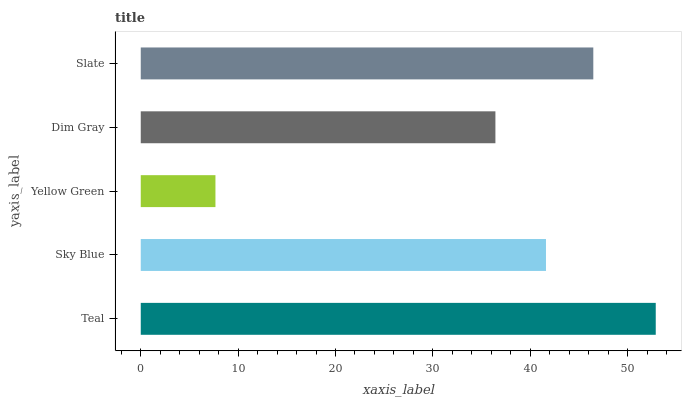Is Yellow Green the minimum?
Answer yes or no. Yes. Is Teal the maximum?
Answer yes or no. Yes. Is Sky Blue the minimum?
Answer yes or no. No. Is Sky Blue the maximum?
Answer yes or no. No. Is Teal greater than Sky Blue?
Answer yes or no. Yes. Is Sky Blue less than Teal?
Answer yes or no. Yes. Is Sky Blue greater than Teal?
Answer yes or no. No. Is Teal less than Sky Blue?
Answer yes or no. No. Is Sky Blue the high median?
Answer yes or no. Yes. Is Sky Blue the low median?
Answer yes or no. Yes. Is Teal the high median?
Answer yes or no. No. Is Teal the low median?
Answer yes or no. No. 